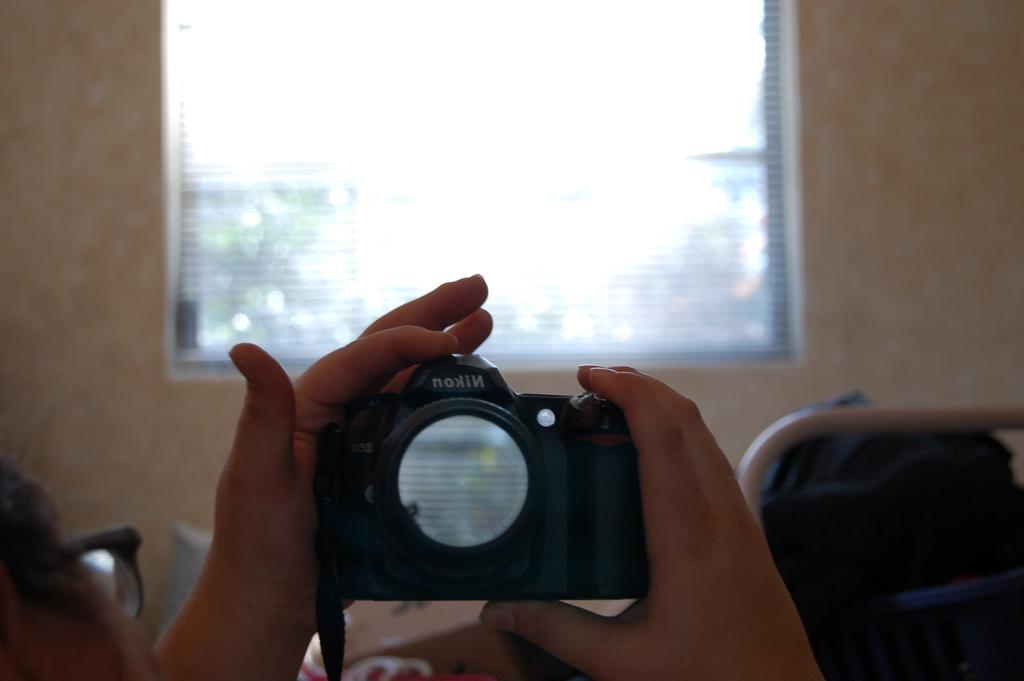What is the main subject of the image? There is a person in the image. Can you describe the person's appearance? The person is wearing spectacles. What is the person doing in the image? The person is laying on a bed. What object is the person holding in their hand? The person is holding a camera in their hand. What can be seen in the background of the image? There is a cream-colored wall and a window in the background. What type of brain is visible on the plate in the image? There is no brain or plate present in the image. Can you describe the person's ability to jump in the image? The person is laying on a bed and not jumping in the image. 